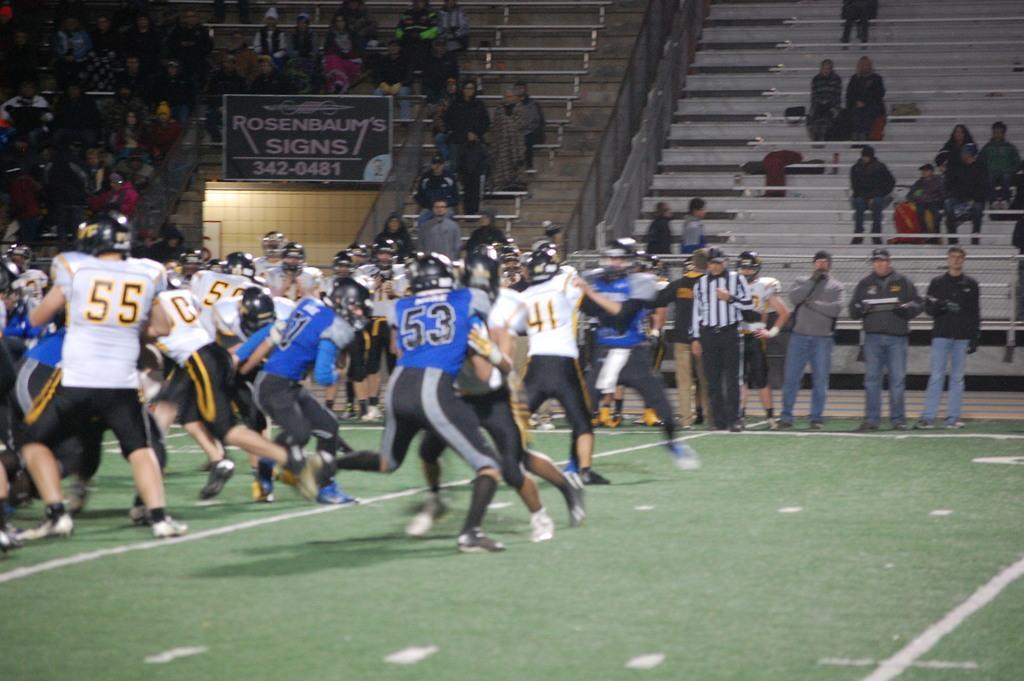Could you give a brief overview of what you see in this image? In this image we can see some group of persons who are playing a game wearing white and blue color dresses respectively and in the background of the image there are some persons standing there is referee who is wearing white and black color dress, there are some spectators sitting on the benches. 